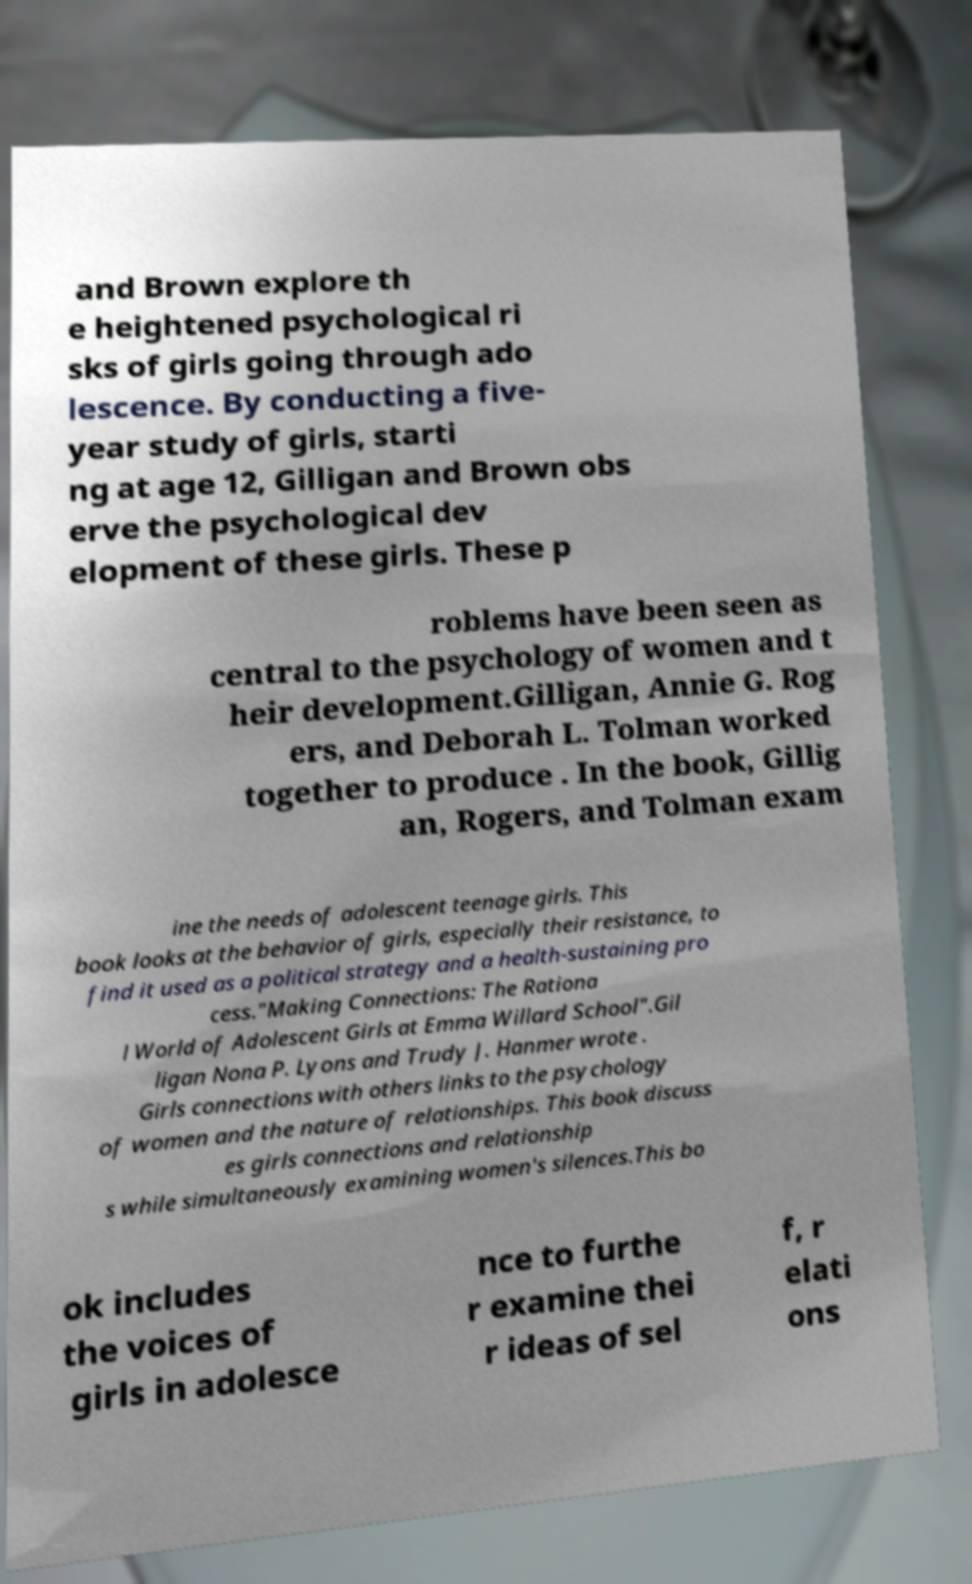Could you extract and type out the text from this image? and Brown explore th e heightened psychological ri sks of girls going through ado lescence. By conducting a five- year study of girls, starti ng at age 12, Gilligan and Brown obs erve the psychological dev elopment of these girls. These p roblems have been seen as central to the psychology of women and t heir development.Gilligan, Annie G. Rog ers, and Deborah L. Tolman worked together to produce . In the book, Gillig an, Rogers, and Tolman exam ine the needs of adolescent teenage girls. This book looks at the behavior of girls, especially their resistance, to find it used as a political strategy and a health-sustaining pro cess."Making Connections: The Rationa l World of Adolescent Girls at Emma Willard School".Gil ligan Nona P. Lyons and Trudy J. Hanmer wrote . Girls connections with others links to the psychology of women and the nature of relationships. This book discuss es girls connections and relationship s while simultaneously examining women's silences.This bo ok includes the voices of girls in adolesce nce to furthe r examine thei r ideas of sel f, r elati ons 